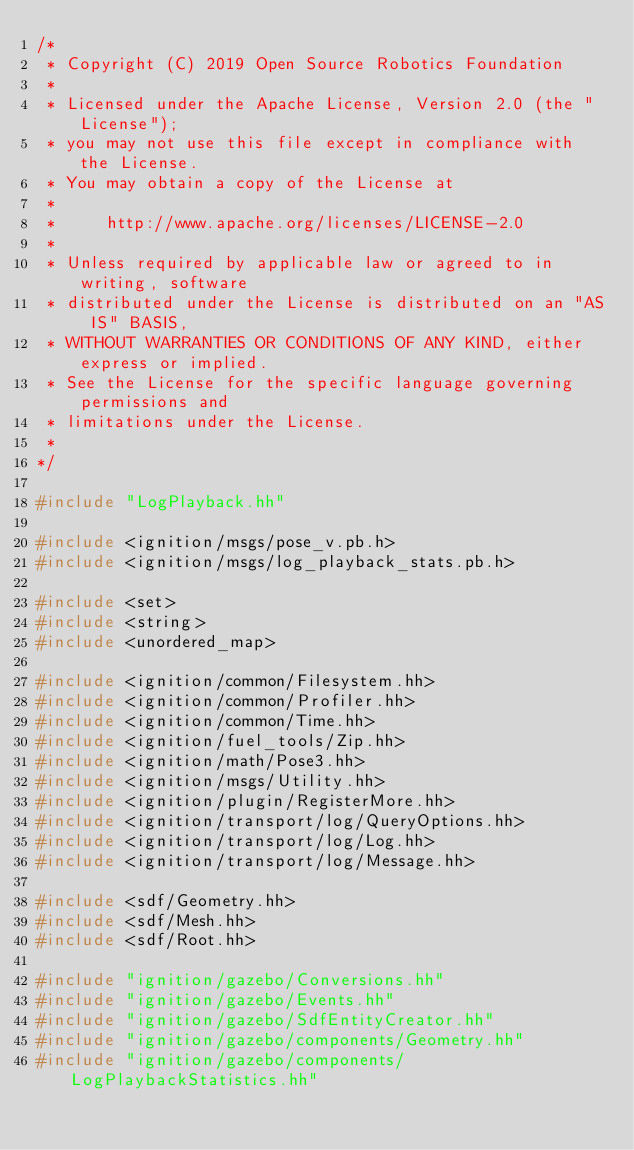Convert code to text. <code><loc_0><loc_0><loc_500><loc_500><_C++_>/*
 * Copyright (C) 2019 Open Source Robotics Foundation
 *
 * Licensed under the Apache License, Version 2.0 (the "License");
 * you may not use this file except in compliance with the License.
 * You may obtain a copy of the License at
 *
 *     http://www.apache.org/licenses/LICENSE-2.0
 *
 * Unless required by applicable law or agreed to in writing, software
 * distributed under the License is distributed on an "AS IS" BASIS,
 * WITHOUT WARRANTIES OR CONDITIONS OF ANY KIND, either express or implied.
 * See the License for the specific language governing permissions and
 * limitations under the License.
 *
*/

#include "LogPlayback.hh"

#include <ignition/msgs/pose_v.pb.h>
#include <ignition/msgs/log_playback_stats.pb.h>

#include <set>
#include <string>
#include <unordered_map>

#include <ignition/common/Filesystem.hh>
#include <ignition/common/Profiler.hh>
#include <ignition/common/Time.hh>
#include <ignition/fuel_tools/Zip.hh>
#include <ignition/math/Pose3.hh>
#include <ignition/msgs/Utility.hh>
#include <ignition/plugin/RegisterMore.hh>
#include <ignition/transport/log/QueryOptions.hh>
#include <ignition/transport/log/Log.hh>
#include <ignition/transport/log/Message.hh>

#include <sdf/Geometry.hh>
#include <sdf/Mesh.hh>
#include <sdf/Root.hh>

#include "ignition/gazebo/Conversions.hh"
#include "ignition/gazebo/Events.hh"
#include "ignition/gazebo/SdfEntityCreator.hh"
#include "ignition/gazebo/components/Geometry.hh"
#include "ignition/gazebo/components/LogPlaybackStatistics.hh"</code> 